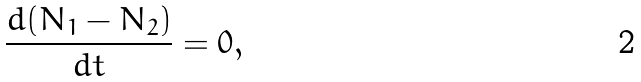Convert formula to latex. <formula><loc_0><loc_0><loc_500><loc_500>\frac { d ( N _ { 1 } - N _ { 2 } ) } { d t } = 0 ,</formula> 